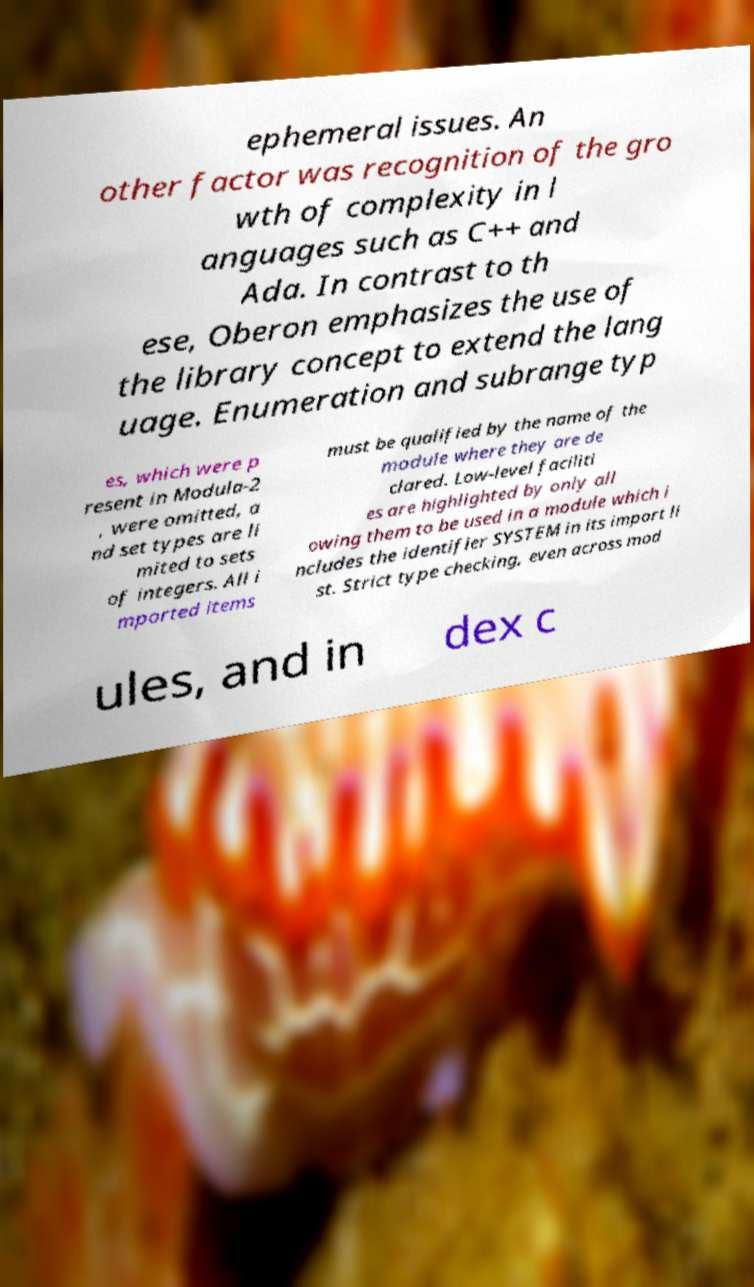Please identify and transcribe the text found in this image. ephemeral issues. An other factor was recognition of the gro wth of complexity in l anguages such as C++ and Ada. In contrast to th ese, Oberon emphasizes the use of the library concept to extend the lang uage. Enumeration and subrange typ es, which were p resent in Modula-2 , were omitted, a nd set types are li mited to sets of integers. All i mported items must be qualified by the name of the module where they are de clared. Low-level faciliti es are highlighted by only all owing them to be used in a module which i ncludes the identifier SYSTEM in its import li st. Strict type checking, even across mod ules, and in dex c 